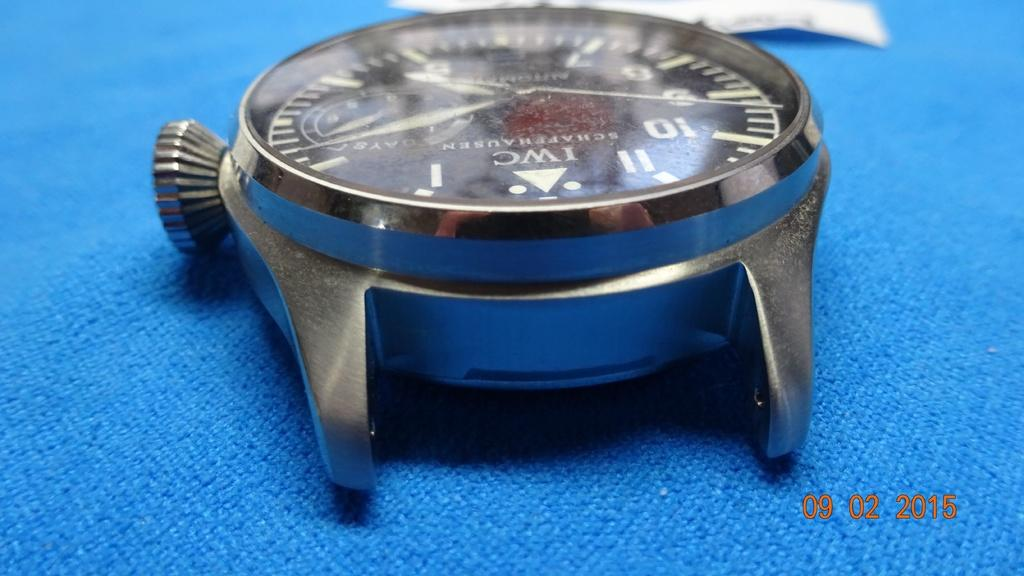Provide a one-sentence caption for the provided image. An IWC watch without a band sits on blue cloth. 